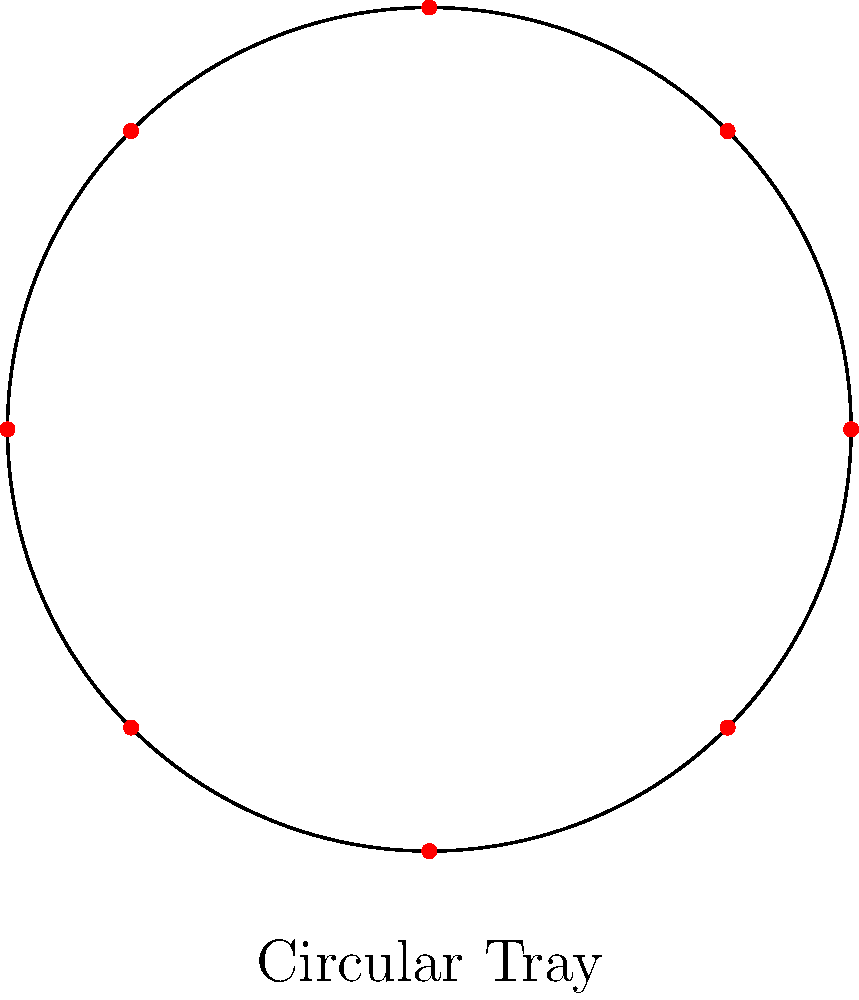You are preparing a circular tray of hors d'oeuvres for a royal banquet. The tray has a radius of 30 cm, and you want to place 8 different types of hors d'oeuvres equally spaced around its circumference. What is the angular separation between each hors d'oeuvre in radians? To solve this problem, we need to follow these steps:

1. Recall that a full circle has $2\pi$ radians.

2. We need to divide the full circle equally among the 8 hors d'oeuvres.

3. The formula for the angular separation is:
   
   $\text{Angular Separation} = \frac{\text{Total angle}}{\text{Number of hors d'oeuvres}}$

4. Substituting the values:
   
   $\text{Angular Separation} = \frac{2\pi}{8}$

5. Simplify:
   
   $\text{Angular Separation} = \frac{\pi}{4}$ radians

This means that each hors d'oeuvre should be placed $\frac{\pi}{4}$ radians apart along the circumference of the tray to ensure equal spacing.
Answer: $\frac{\pi}{4}$ radians 